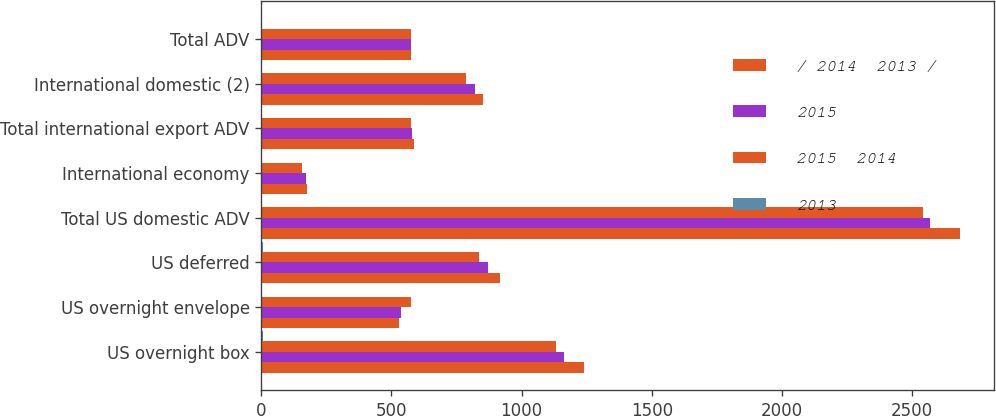<chart> <loc_0><loc_0><loc_500><loc_500><stacked_bar_chart><ecel><fcel>US overnight box<fcel>US overnight envelope<fcel>US deferred<fcel>Total US domestic ADV<fcel>International economy<fcel>Total international export ADV<fcel>International domestic (2)<fcel>Total ADV<nl><fcel>/ 2014  2013 /<fcel>1240<fcel>527<fcel>916<fcel>2683<fcel>176<fcel>586<fcel>853<fcel>576<nl><fcel>2015<fcel>1164<fcel>538<fcel>869<fcel>2571<fcel>170<fcel>580<fcel>819<fcel>576<nl><fcel>2015  2014<fcel>1134<fcel>574<fcel>835<fcel>2543<fcel>155<fcel>576<fcel>785<fcel>576<nl><fcel>2013<fcel>7<fcel>2<fcel>5<fcel>4<fcel>4<fcel>1<fcel>4<fcel>4<nl></chart> 